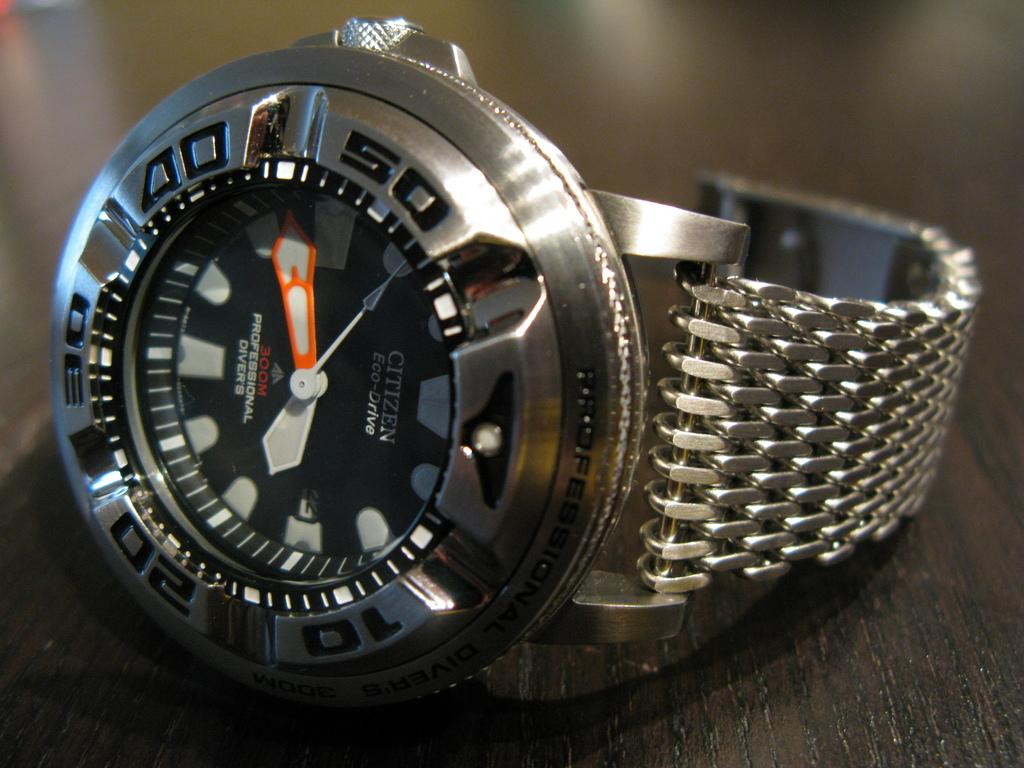<image>
Create a compact narrative representing the image presented. A silver colored Citizen Eco-Drive watch rests on a dark counter. 